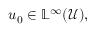<formula> <loc_0><loc_0><loc_500><loc_500>u _ { 0 } \in \mathbb { L } ^ { \infty } ( \mathcal { U } ) ,</formula> 